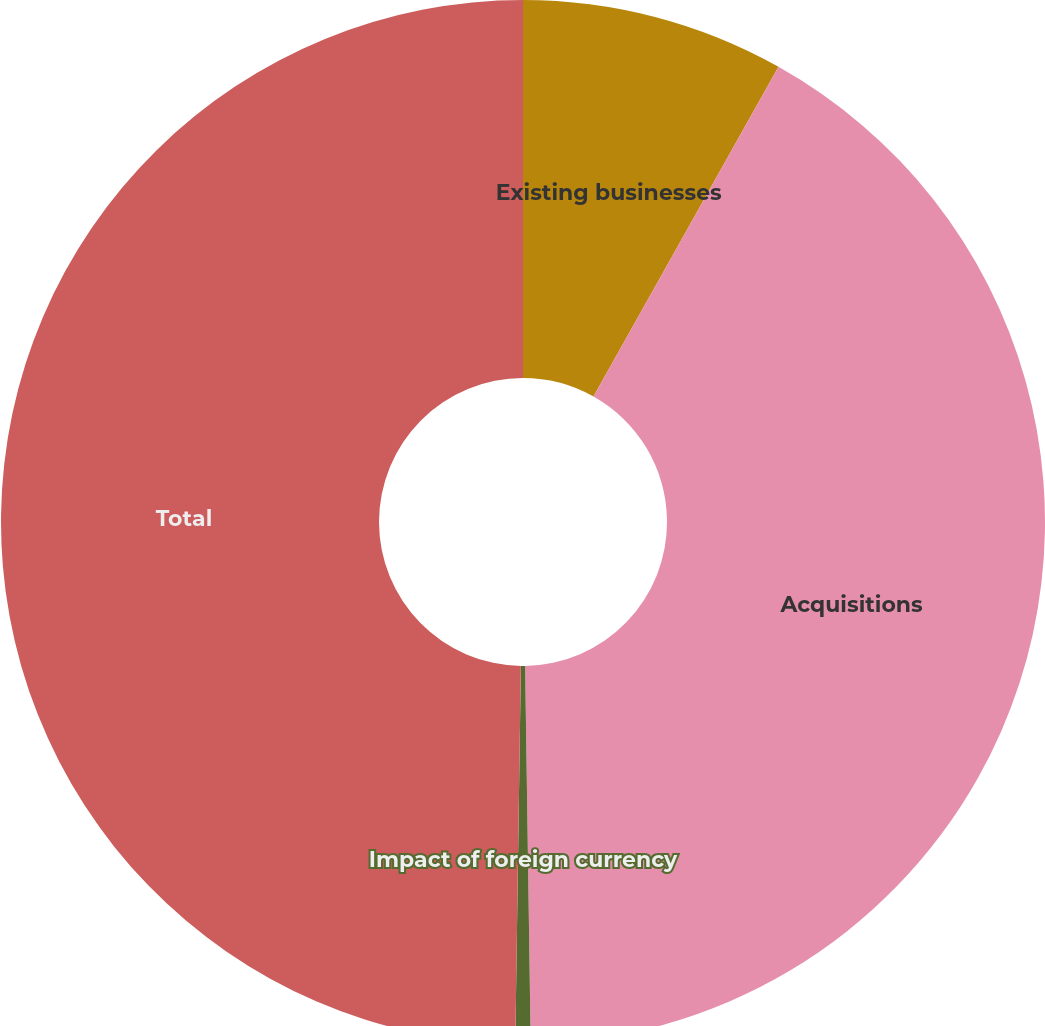<chart> <loc_0><loc_0><loc_500><loc_500><pie_chart><fcel>Existing businesses<fcel>Acquisitions<fcel>Impact of foreign currency<fcel>Total<nl><fcel>8.14%<fcel>41.62%<fcel>0.47%<fcel>49.76%<nl></chart> 